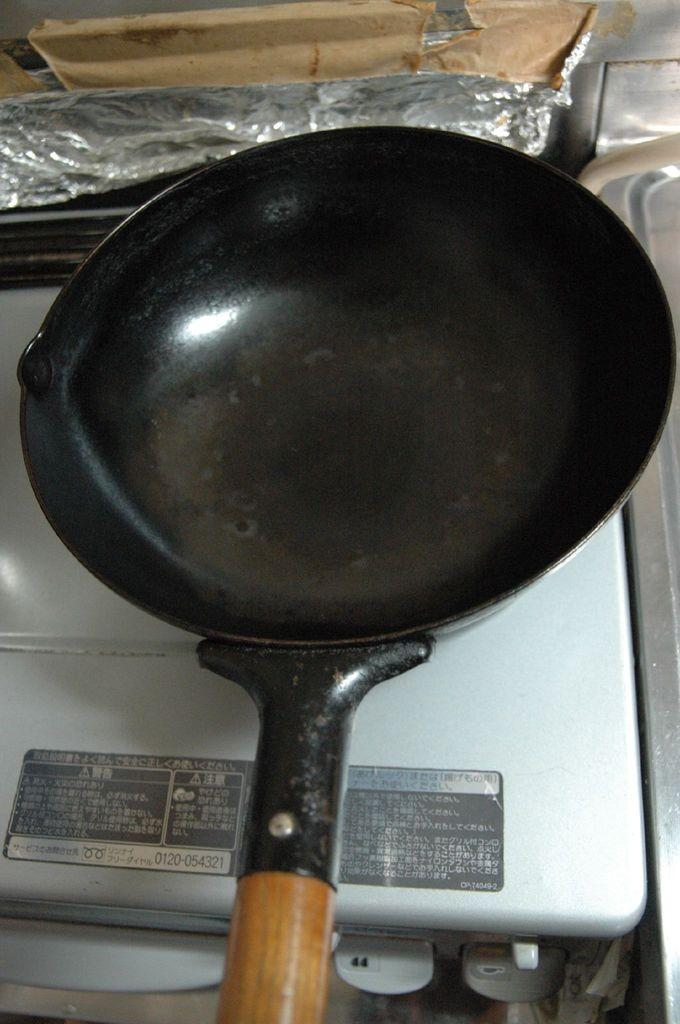What is on the stove in the image? There is a pan on the stove in the image. Can you describe anything in the background of the image? There is a silver foil in the background of the image. What route does the knife take to reach the pan in the image? There is no knife present in the image, so it cannot take any route to reach the pan. 